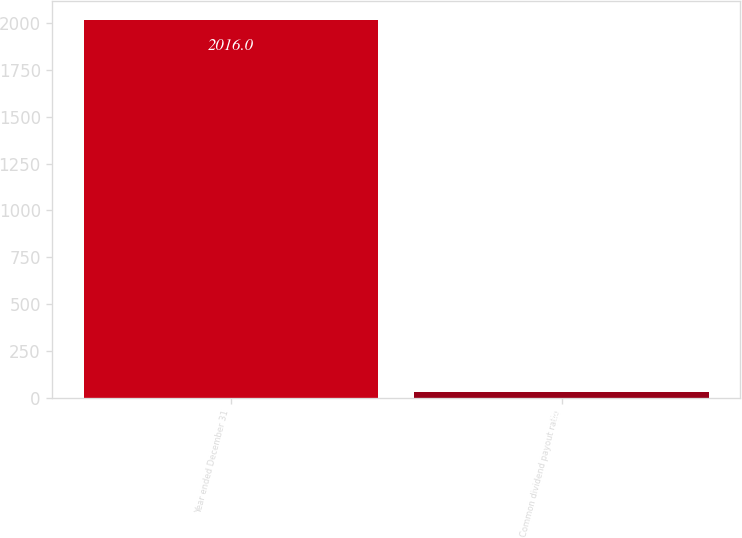Convert chart. <chart><loc_0><loc_0><loc_500><loc_500><bar_chart><fcel>Year ended December 31<fcel>Common dividend payout ratio<nl><fcel>2016<fcel>30<nl></chart> 